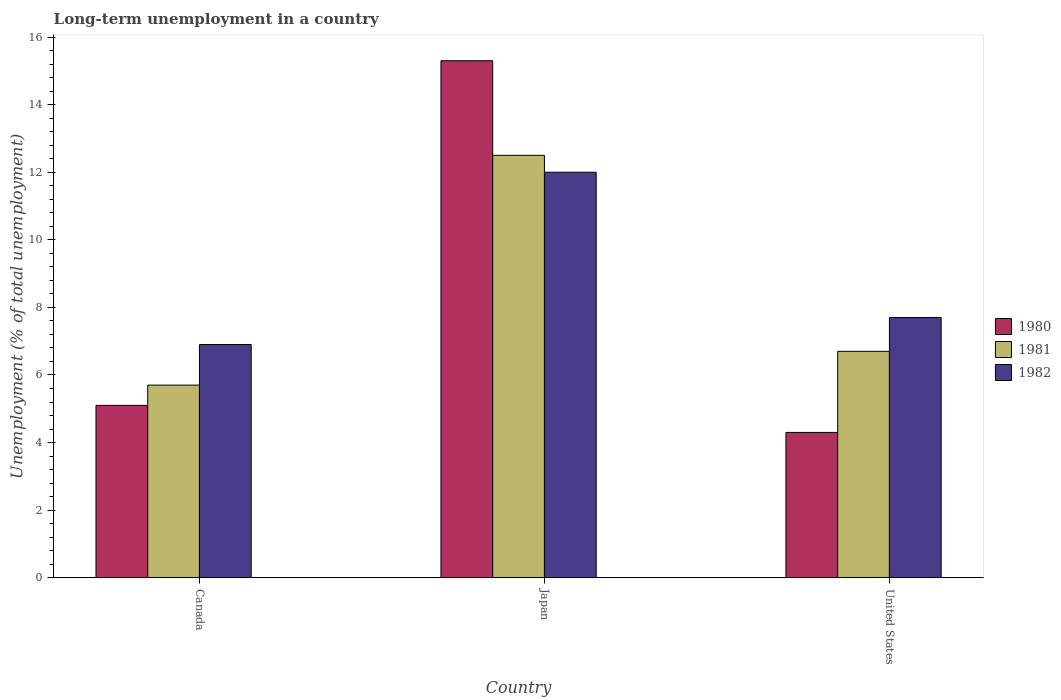How many groups of bars are there?
Ensure brevity in your answer.  3. Are the number of bars on each tick of the X-axis equal?
Keep it short and to the point. Yes. How many bars are there on the 1st tick from the right?
Provide a short and direct response. 3. What is the label of the 2nd group of bars from the left?
Provide a succinct answer. Japan. In how many cases, is the number of bars for a given country not equal to the number of legend labels?
Offer a very short reply. 0. What is the percentage of long-term unemployed population in 1980 in United States?
Offer a terse response. 4.3. Across all countries, what is the minimum percentage of long-term unemployed population in 1981?
Make the answer very short. 5.7. In which country was the percentage of long-term unemployed population in 1980 minimum?
Your answer should be very brief. United States. What is the total percentage of long-term unemployed population in 1980 in the graph?
Offer a terse response. 24.7. What is the difference between the percentage of long-term unemployed population in 1980 in Canada and that in United States?
Give a very brief answer. 0.8. What is the difference between the percentage of long-term unemployed population in 1982 in Canada and the percentage of long-term unemployed population in 1981 in United States?
Keep it short and to the point. 0.2. What is the average percentage of long-term unemployed population in 1981 per country?
Offer a very short reply. 8.3. What is the difference between the percentage of long-term unemployed population of/in 1982 and percentage of long-term unemployed population of/in 1980 in Canada?
Your answer should be very brief. 1.8. In how many countries, is the percentage of long-term unemployed population in 1982 greater than 13.6 %?
Keep it short and to the point. 0. What is the ratio of the percentage of long-term unemployed population in 1980 in Canada to that in United States?
Ensure brevity in your answer.  1.19. Is the difference between the percentage of long-term unemployed population in 1982 in Canada and United States greater than the difference between the percentage of long-term unemployed population in 1980 in Canada and United States?
Your response must be concise. No. What is the difference between the highest and the second highest percentage of long-term unemployed population in 1982?
Keep it short and to the point. 5.1. What is the difference between the highest and the lowest percentage of long-term unemployed population in 1982?
Your response must be concise. 5.1. What does the 2nd bar from the right in Japan represents?
Give a very brief answer. 1981. Is it the case that in every country, the sum of the percentage of long-term unemployed population in 1980 and percentage of long-term unemployed population in 1981 is greater than the percentage of long-term unemployed population in 1982?
Give a very brief answer. Yes. How many bars are there?
Ensure brevity in your answer.  9. Are all the bars in the graph horizontal?
Offer a very short reply. No. What is the difference between two consecutive major ticks on the Y-axis?
Your answer should be compact. 2. Does the graph contain grids?
Ensure brevity in your answer.  No. What is the title of the graph?
Make the answer very short. Long-term unemployment in a country. Does "2001" appear as one of the legend labels in the graph?
Provide a succinct answer. No. What is the label or title of the X-axis?
Provide a succinct answer. Country. What is the label or title of the Y-axis?
Offer a very short reply. Unemployment (% of total unemployment). What is the Unemployment (% of total unemployment) in 1980 in Canada?
Provide a short and direct response. 5.1. What is the Unemployment (% of total unemployment) in 1981 in Canada?
Make the answer very short. 5.7. What is the Unemployment (% of total unemployment) of 1982 in Canada?
Your answer should be compact. 6.9. What is the Unemployment (% of total unemployment) of 1980 in Japan?
Your answer should be very brief. 15.3. What is the Unemployment (% of total unemployment) in 1981 in Japan?
Your answer should be very brief. 12.5. What is the Unemployment (% of total unemployment) of 1980 in United States?
Give a very brief answer. 4.3. What is the Unemployment (% of total unemployment) in 1981 in United States?
Provide a short and direct response. 6.7. What is the Unemployment (% of total unemployment) in 1982 in United States?
Your answer should be compact. 7.7. Across all countries, what is the maximum Unemployment (% of total unemployment) in 1980?
Your response must be concise. 15.3. Across all countries, what is the maximum Unemployment (% of total unemployment) of 1981?
Your response must be concise. 12.5. Across all countries, what is the minimum Unemployment (% of total unemployment) in 1980?
Provide a short and direct response. 4.3. Across all countries, what is the minimum Unemployment (% of total unemployment) of 1981?
Ensure brevity in your answer.  5.7. Across all countries, what is the minimum Unemployment (% of total unemployment) of 1982?
Your answer should be compact. 6.9. What is the total Unemployment (% of total unemployment) in 1980 in the graph?
Your response must be concise. 24.7. What is the total Unemployment (% of total unemployment) of 1981 in the graph?
Provide a succinct answer. 24.9. What is the total Unemployment (% of total unemployment) in 1982 in the graph?
Ensure brevity in your answer.  26.6. What is the difference between the Unemployment (% of total unemployment) of 1982 in Canada and that in Japan?
Your response must be concise. -5.1. What is the difference between the Unemployment (% of total unemployment) of 1982 in Canada and that in United States?
Make the answer very short. -0.8. What is the difference between the Unemployment (% of total unemployment) of 1981 in Japan and that in United States?
Provide a short and direct response. 5.8. What is the difference between the Unemployment (% of total unemployment) in 1982 in Japan and that in United States?
Provide a short and direct response. 4.3. What is the difference between the Unemployment (% of total unemployment) in 1980 in Canada and the Unemployment (% of total unemployment) in 1981 in Japan?
Your answer should be very brief. -7.4. What is the difference between the Unemployment (% of total unemployment) of 1981 in Canada and the Unemployment (% of total unemployment) of 1982 in Japan?
Provide a succinct answer. -6.3. What is the difference between the Unemployment (% of total unemployment) in 1980 in Canada and the Unemployment (% of total unemployment) in 1981 in United States?
Ensure brevity in your answer.  -1.6. What is the difference between the Unemployment (% of total unemployment) in 1980 in Japan and the Unemployment (% of total unemployment) in 1982 in United States?
Your answer should be compact. 7.6. What is the average Unemployment (% of total unemployment) in 1980 per country?
Give a very brief answer. 8.23. What is the average Unemployment (% of total unemployment) in 1982 per country?
Make the answer very short. 8.87. What is the difference between the Unemployment (% of total unemployment) in 1980 and Unemployment (% of total unemployment) in 1981 in Canada?
Your answer should be compact. -0.6. What is the difference between the Unemployment (% of total unemployment) of 1980 and Unemployment (% of total unemployment) of 1982 in Canada?
Your answer should be very brief. -1.8. What is the difference between the Unemployment (% of total unemployment) in 1980 and Unemployment (% of total unemployment) in 1981 in United States?
Offer a very short reply. -2.4. What is the difference between the Unemployment (% of total unemployment) of 1980 and Unemployment (% of total unemployment) of 1982 in United States?
Provide a short and direct response. -3.4. What is the ratio of the Unemployment (% of total unemployment) of 1980 in Canada to that in Japan?
Your answer should be compact. 0.33. What is the ratio of the Unemployment (% of total unemployment) of 1981 in Canada to that in Japan?
Offer a very short reply. 0.46. What is the ratio of the Unemployment (% of total unemployment) in 1982 in Canada to that in Japan?
Keep it short and to the point. 0.57. What is the ratio of the Unemployment (% of total unemployment) of 1980 in Canada to that in United States?
Provide a succinct answer. 1.19. What is the ratio of the Unemployment (% of total unemployment) in 1981 in Canada to that in United States?
Your response must be concise. 0.85. What is the ratio of the Unemployment (% of total unemployment) of 1982 in Canada to that in United States?
Your answer should be compact. 0.9. What is the ratio of the Unemployment (% of total unemployment) in 1980 in Japan to that in United States?
Offer a terse response. 3.56. What is the ratio of the Unemployment (% of total unemployment) in 1981 in Japan to that in United States?
Ensure brevity in your answer.  1.87. What is the ratio of the Unemployment (% of total unemployment) in 1982 in Japan to that in United States?
Your answer should be compact. 1.56. What is the difference between the highest and the second highest Unemployment (% of total unemployment) of 1980?
Ensure brevity in your answer.  10.2. 